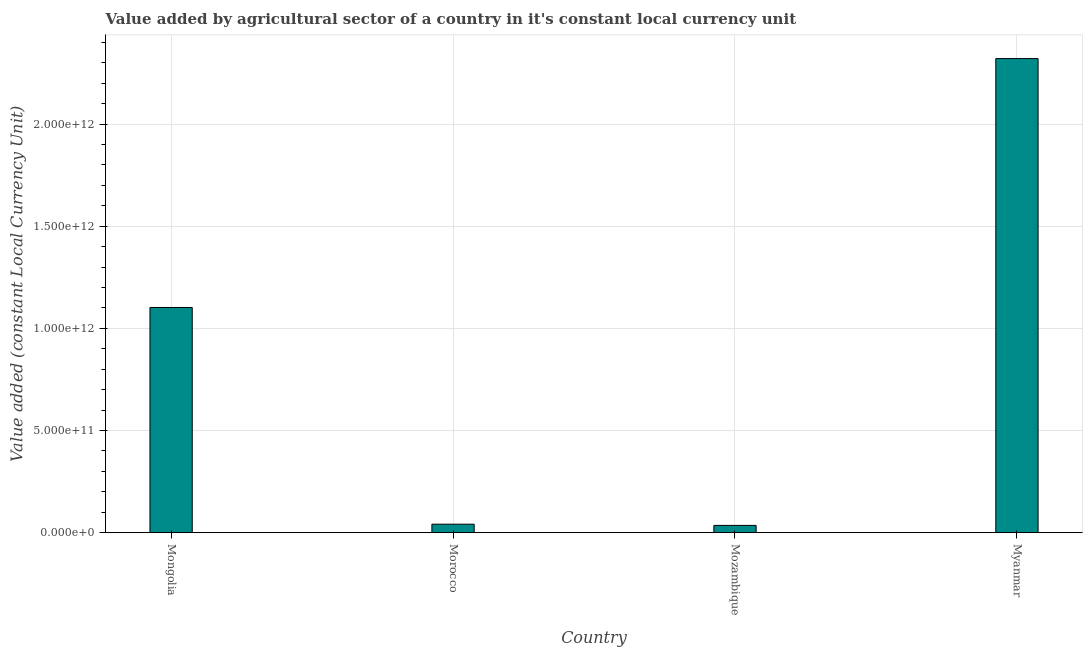Does the graph contain grids?
Make the answer very short. Yes. What is the title of the graph?
Make the answer very short. Value added by agricultural sector of a country in it's constant local currency unit. What is the label or title of the Y-axis?
Give a very brief answer. Value added (constant Local Currency Unit). What is the value added by agriculture sector in Mozambique?
Your answer should be very brief. 3.58e+1. Across all countries, what is the maximum value added by agriculture sector?
Provide a short and direct response. 2.32e+12. Across all countries, what is the minimum value added by agriculture sector?
Make the answer very short. 3.58e+1. In which country was the value added by agriculture sector maximum?
Ensure brevity in your answer.  Myanmar. In which country was the value added by agriculture sector minimum?
Your answer should be compact. Mozambique. What is the sum of the value added by agriculture sector?
Provide a short and direct response. 3.50e+12. What is the difference between the value added by agriculture sector in Morocco and Myanmar?
Make the answer very short. -2.28e+12. What is the average value added by agriculture sector per country?
Your response must be concise. 8.75e+11. What is the median value added by agriculture sector?
Your response must be concise. 5.72e+11. What is the ratio of the value added by agriculture sector in Mongolia to that in Myanmar?
Your answer should be compact. 0.47. What is the difference between the highest and the second highest value added by agriculture sector?
Ensure brevity in your answer.  1.22e+12. What is the difference between the highest and the lowest value added by agriculture sector?
Provide a short and direct response. 2.29e+12. How many bars are there?
Provide a short and direct response. 4. How many countries are there in the graph?
Your answer should be compact. 4. What is the difference between two consecutive major ticks on the Y-axis?
Your response must be concise. 5.00e+11. What is the Value added (constant Local Currency Unit) in Mongolia?
Make the answer very short. 1.10e+12. What is the Value added (constant Local Currency Unit) in Morocco?
Your answer should be very brief. 4.17e+1. What is the Value added (constant Local Currency Unit) in Mozambique?
Ensure brevity in your answer.  3.58e+1. What is the Value added (constant Local Currency Unit) of Myanmar?
Provide a short and direct response. 2.32e+12. What is the difference between the Value added (constant Local Currency Unit) in Mongolia and Morocco?
Provide a succinct answer. 1.06e+12. What is the difference between the Value added (constant Local Currency Unit) in Mongolia and Mozambique?
Keep it short and to the point. 1.07e+12. What is the difference between the Value added (constant Local Currency Unit) in Mongolia and Myanmar?
Provide a short and direct response. -1.22e+12. What is the difference between the Value added (constant Local Currency Unit) in Morocco and Mozambique?
Offer a terse response. 5.89e+09. What is the difference between the Value added (constant Local Currency Unit) in Morocco and Myanmar?
Offer a very short reply. -2.28e+12. What is the difference between the Value added (constant Local Currency Unit) in Mozambique and Myanmar?
Your answer should be compact. -2.29e+12. What is the ratio of the Value added (constant Local Currency Unit) in Mongolia to that in Morocco?
Provide a short and direct response. 26.46. What is the ratio of the Value added (constant Local Currency Unit) in Mongolia to that in Mozambique?
Provide a succinct answer. 30.82. What is the ratio of the Value added (constant Local Currency Unit) in Mongolia to that in Myanmar?
Provide a succinct answer. 0.47. What is the ratio of the Value added (constant Local Currency Unit) in Morocco to that in Mozambique?
Provide a succinct answer. 1.17. What is the ratio of the Value added (constant Local Currency Unit) in Morocco to that in Myanmar?
Provide a short and direct response. 0.02. What is the ratio of the Value added (constant Local Currency Unit) in Mozambique to that in Myanmar?
Your response must be concise. 0.01. 